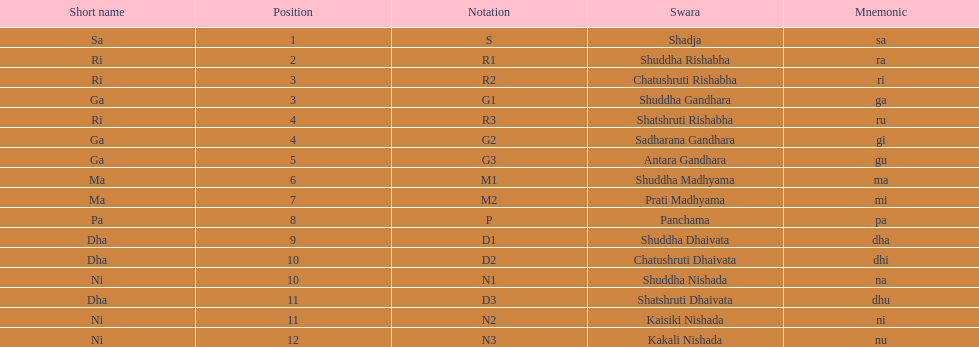What is the name of the swara that holds the first position? Shadja. 